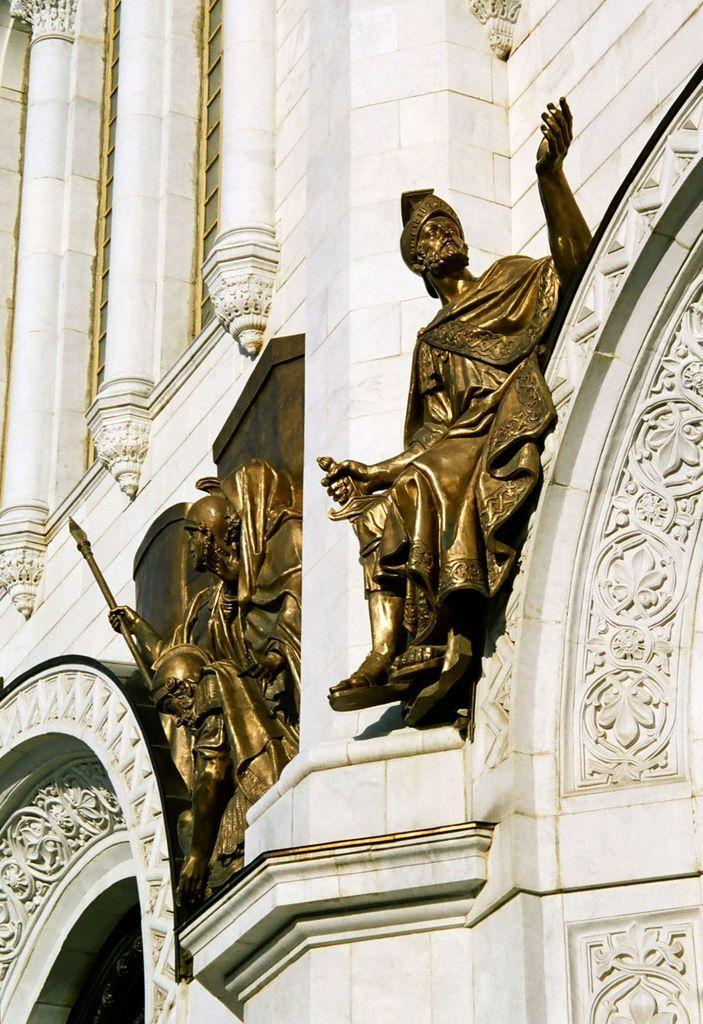In one or two sentences, can you explain what this image depicts? In this image in the center there is a building and on the building there are statues. 